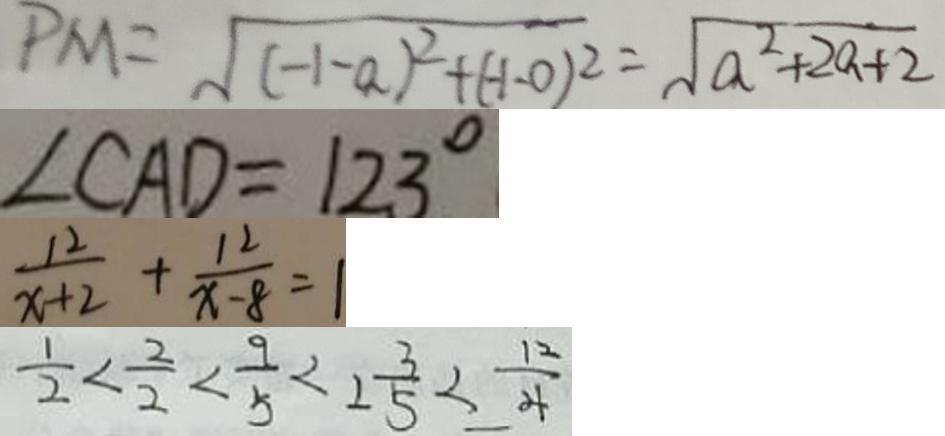<formula> <loc_0><loc_0><loc_500><loc_500>P M = \sqrt { ( - 1 - a ) ^ { 2 } + ( - 1 - 0 ) ^ { 2 } } = \sqrt { a ^ { 2 } + 2 a + 2 } 
 \angle C A D = 1 2 3 ^ { \circ } 
 \frac { 1 2 } { x + 2 } + \frac { 1 2 } { x - 8 } = 1 
 \frac { 1 } { 2 } < \frac { 2 } { 2 } < \frac { 9 } { 5 } < 2 \frac { 3 } { 5 } < \frac { 1 2 } { 4 }</formula> 